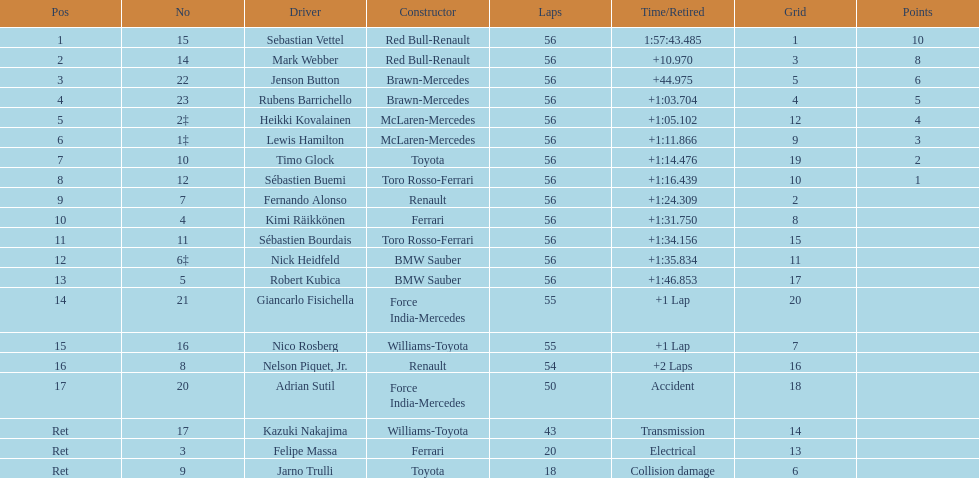What was jenson button's time? +44.975. 